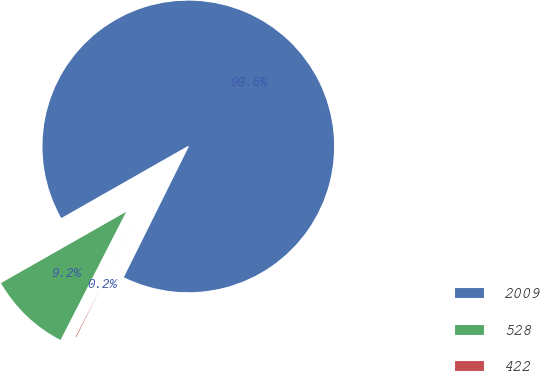<chart> <loc_0><loc_0><loc_500><loc_500><pie_chart><fcel>2009<fcel>528<fcel>422<nl><fcel>90.58%<fcel>9.23%<fcel>0.19%<nl></chart> 